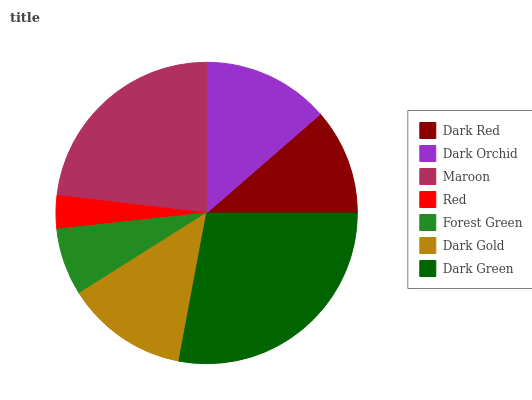Is Red the minimum?
Answer yes or no. Yes. Is Dark Green the maximum?
Answer yes or no. Yes. Is Dark Orchid the minimum?
Answer yes or no. No. Is Dark Orchid the maximum?
Answer yes or no. No. Is Dark Orchid greater than Dark Red?
Answer yes or no. Yes. Is Dark Red less than Dark Orchid?
Answer yes or no. Yes. Is Dark Red greater than Dark Orchid?
Answer yes or no. No. Is Dark Orchid less than Dark Red?
Answer yes or no. No. Is Dark Gold the high median?
Answer yes or no. Yes. Is Dark Gold the low median?
Answer yes or no. Yes. Is Forest Green the high median?
Answer yes or no. No. Is Dark Green the low median?
Answer yes or no. No. 